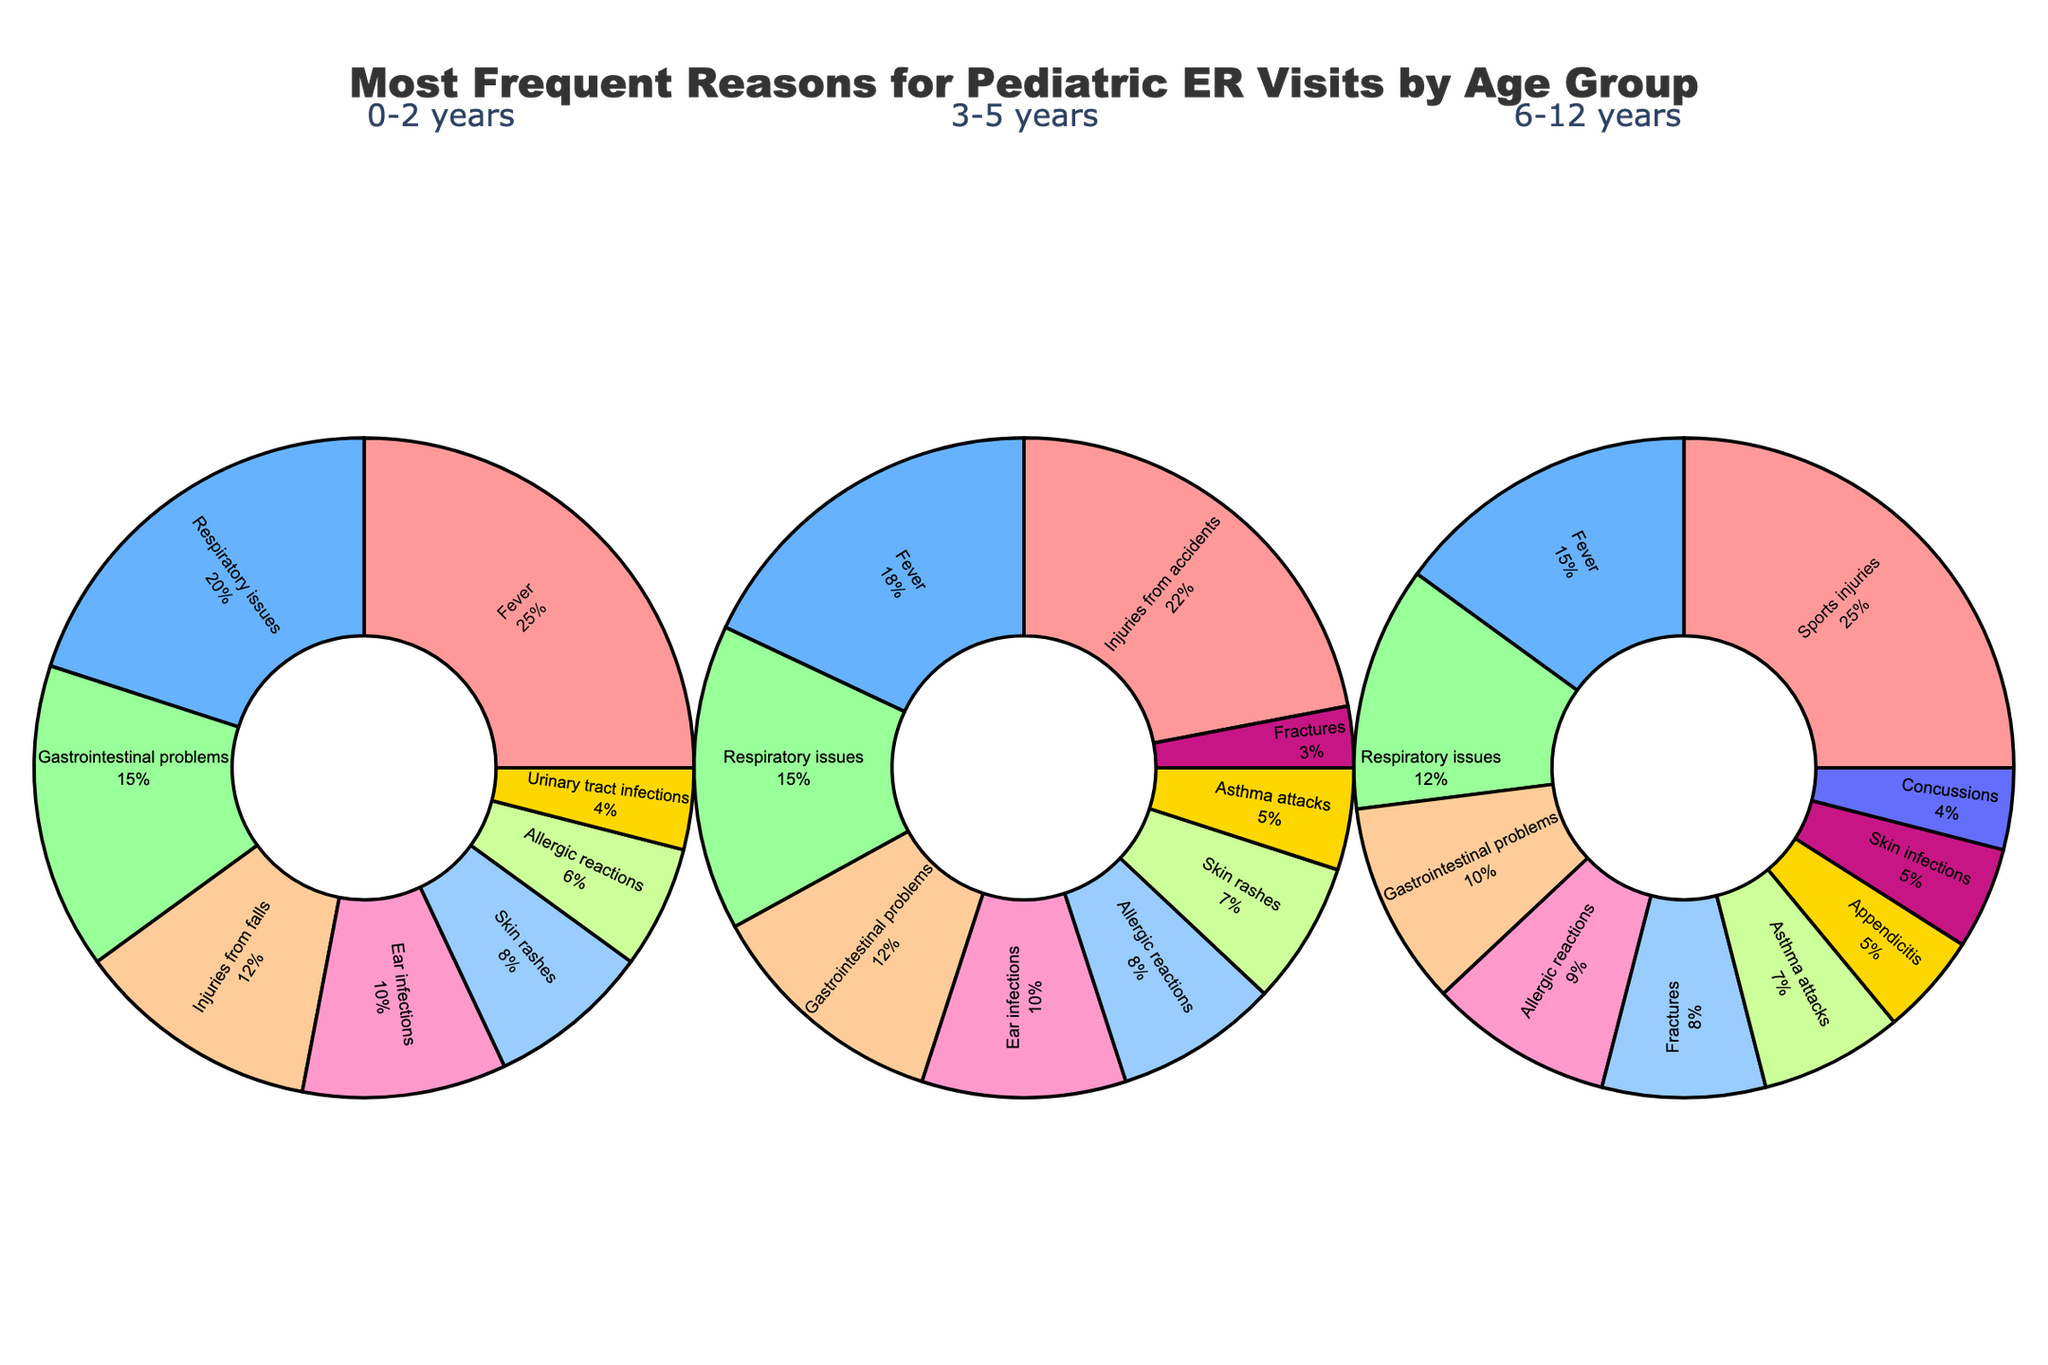What's the most frequent reason for pediatric ER visits in the 0-2 years age group? To find the most frequent reason, we look for the reason with the highest percentage in the 0-2 years pie chart. Fever is 25%, which is the highest.
Answer: Fever Which reason is more common in the 3-5 years age group: Fractures or Asthma attacks? By comparing the percentages of Fractures and Asthma attacks in the 3-5 years pie chart, Fractures is 3% and Asthma attacks is 5%. Asthma attacks is higher.
Answer: Asthma attacks Are skin-related issues (rashes and infections) more common in the 0-2 years age group or the 6-12 years age group? Sum the percentages of Skin rashes (8%) and Skin infections (0%) for the 0-2 years group, which equals 8%. Sum percentages of Skin rashes (0%) and Skin infections (5%) for the 6-12 years group, which equals 5%. Thus, skin-related issues are more common in the 0-2 years group.
Answer: 0-2 years What is the combined percentage of Fever-related ER visits across all age groups? Sum the percentages of Fever in all age groups (0-2 years: 25%, 3-5 years: 18%, 6-12 years: 15%). Total is 25 + 18 + 15 = 58%.
Answer: 58% Which reason occupies the largest portion of the pie in the 6-12 years age group? To find the largest portion, look for the reason with the highest percentage in the 6-12 years pie chart. Sports injuries is 25%, the highest.
Answer: Sports injuries Is the percentage of Respiratory issues higher in the 0-2 years age group or the 3-5 years age group? Comparing percentages of Respiratory issues in 0-2 years (20%) and 3-5 years (15%), 0-2 years has a higher percentage.
Answer: 0-2 years Are Injuries from falls in the 0-2 years group more or less frequent than Injuries from accidents in the 3-5 years group? Comparing Injuries from falls (12%) in 0-2 years with Injuries from accidents (22%) in 3-5 years shows that it is less frequent in the 0-2 years group.
Answer: Less frequent What is the difference in percentage between the most common and the least common reason for ER visits in the 3-5 years age group? In the 3-5 years group, the most common reason is Injuries from accidents (22%) and the least common is Fractures (3%). The difference is 22 - 3 = 19%.
Answer: 19% Which has a higher percentage of ER visits for Gastrointestinal problems, the 0-2 years or the 6-12 years age group? Gastrointestinal problems are 15% in the 0-2 years group and 10% in the 6-12 years group. The 0-2 years group has a higher percentage.
Answer: 0-2 years 